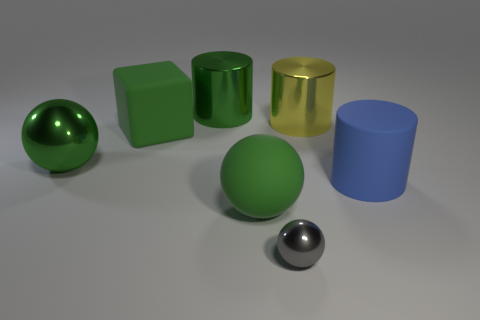Add 1 blue cylinders. How many objects exist? 8 Subtract all balls. How many objects are left? 4 Add 1 large gray rubber cubes. How many large gray rubber cubes exist? 1 Subtract 0 yellow spheres. How many objects are left? 7 Subtract all spheres. Subtract all blue cylinders. How many objects are left? 3 Add 3 big cubes. How many big cubes are left? 4 